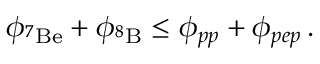Convert formula to latex. <formula><loc_0><loc_0><loc_500><loc_500>\phi _ { ^ { 7 } B e } + \phi _ { ^ { 8 } B } \leq \phi _ { p p } + \phi _ { p e p } \, .</formula> 